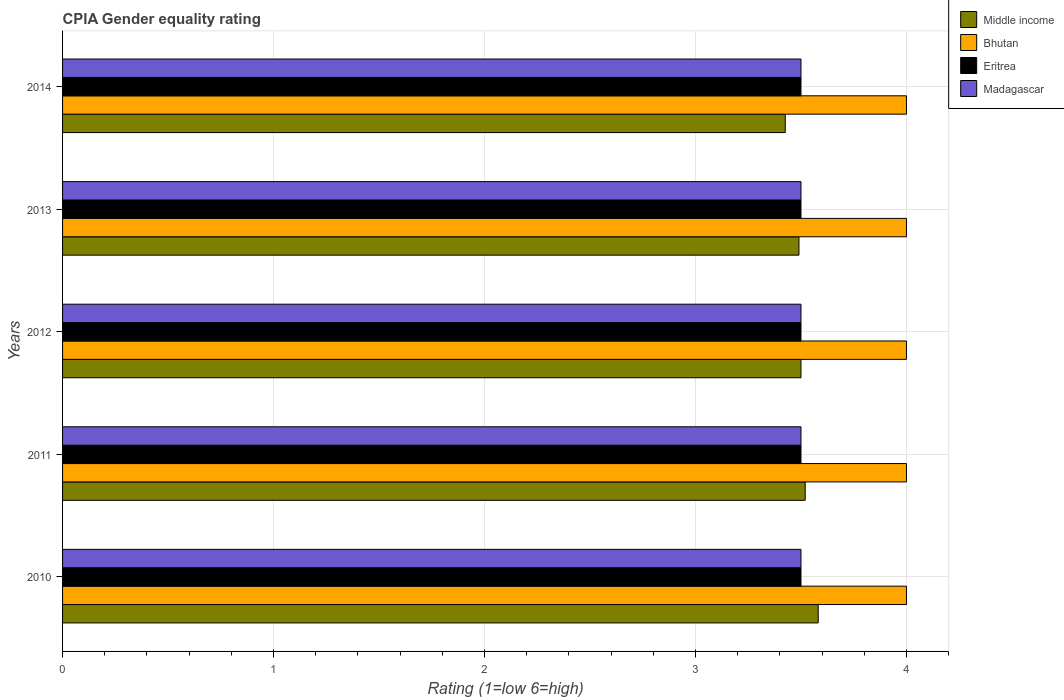How many different coloured bars are there?
Provide a short and direct response. 4. Are the number of bars per tick equal to the number of legend labels?
Your response must be concise. Yes. How many bars are there on the 5th tick from the top?
Provide a short and direct response. 4. In how many cases, is the number of bars for a given year not equal to the number of legend labels?
Your response must be concise. 0. What is the CPIA rating in Middle income in 2014?
Keep it short and to the point. 3.43. Across all years, what is the maximum CPIA rating in Bhutan?
Your answer should be very brief. 4. In which year was the CPIA rating in Bhutan minimum?
Your answer should be compact. 2010. What is the difference between the CPIA rating in Madagascar in 2010 and the CPIA rating in Eritrea in 2012?
Offer a very short reply. 0. In the year 2010, what is the difference between the CPIA rating in Bhutan and CPIA rating in Middle income?
Ensure brevity in your answer.  0.42. What is the difference between the highest and the second highest CPIA rating in Middle income?
Offer a very short reply. 0.06. What is the difference between the highest and the lowest CPIA rating in Middle income?
Provide a short and direct response. 0.16. Is it the case that in every year, the sum of the CPIA rating in Bhutan and CPIA rating in Madagascar is greater than the sum of CPIA rating in Middle income and CPIA rating in Eritrea?
Your answer should be very brief. Yes. What does the 2nd bar from the top in 2014 represents?
Your answer should be compact. Eritrea. What does the 3rd bar from the bottom in 2010 represents?
Your answer should be compact. Eritrea. Is it the case that in every year, the sum of the CPIA rating in Middle income and CPIA rating in Bhutan is greater than the CPIA rating in Eritrea?
Give a very brief answer. Yes. Are all the bars in the graph horizontal?
Your answer should be very brief. Yes. Are the values on the major ticks of X-axis written in scientific E-notation?
Your answer should be very brief. No. Does the graph contain any zero values?
Your answer should be compact. No. How many legend labels are there?
Make the answer very short. 4. What is the title of the graph?
Ensure brevity in your answer.  CPIA Gender equality rating. What is the label or title of the X-axis?
Your answer should be compact. Rating (1=low 6=high). What is the Rating (1=low 6=high) in Middle income in 2010?
Keep it short and to the point. 3.58. What is the Rating (1=low 6=high) in Middle income in 2011?
Provide a short and direct response. 3.52. What is the Rating (1=low 6=high) in Madagascar in 2011?
Your answer should be very brief. 3.5. What is the Rating (1=low 6=high) in Eritrea in 2012?
Your answer should be very brief. 3.5. What is the Rating (1=low 6=high) in Madagascar in 2012?
Make the answer very short. 3.5. What is the Rating (1=low 6=high) in Middle income in 2013?
Offer a terse response. 3.49. What is the Rating (1=low 6=high) in Bhutan in 2013?
Your response must be concise. 4. What is the Rating (1=low 6=high) of Middle income in 2014?
Provide a short and direct response. 3.43. What is the Rating (1=low 6=high) in Eritrea in 2014?
Your answer should be compact. 3.5. What is the Rating (1=low 6=high) of Madagascar in 2014?
Your response must be concise. 3.5. Across all years, what is the maximum Rating (1=low 6=high) in Middle income?
Your answer should be compact. 3.58. Across all years, what is the maximum Rating (1=low 6=high) in Madagascar?
Keep it short and to the point. 3.5. Across all years, what is the minimum Rating (1=low 6=high) in Middle income?
Offer a very short reply. 3.43. Across all years, what is the minimum Rating (1=low 6=high) in Madagascar?
Your response must be concise. 3.5. What is the total Rating (1=low 6=high) in Middle income in the graph?
Provide a short and direct response. 17.52. What is the difference between the Rating (1=low 6=high) of Middle income in 2010 and that in 2011?
Your answer should be compact. 0.06. What is the difference between the Rating (1=low 6=high) in Madagascar in 2010 and that in 2011?
Keep it short and to the point. 0. What is the difference between the Rating (1=low 6=high) of Middle income in 2010 and that in 2012?
Your answer should be compact. 0.08. What is the difference between the Rating (1=low 6=high) in Eritrea in 2010 and that in 2012?
Your response must be concise. 0. What is the difference between the Rating (1=low 6=high) in Madagascar in 2010 and that in 2012?
Ensure brevity in your answer.  0. What is the difference between the Rating (1=low 6=high) of Middle income in 2010 and that in 2013?
Your response must be concise. 0.09. What is the difference between the Rating (1=low 6=high) of Bhutan in 2010 and that in 2013?
Offer a terse response. 0. What is the difference between the Rating (1=low 6=high) in Madagascar in 2010 and that in 2013?
Provide a short and direct response. 0. What is the difference between the Rating (1=low 6=high) of Middle income in 2010 and that in 2014?
Keep it short and to the point. 0.16. What is the difference between the Rating (1=low 6=high) in Eritrea in 2010 and that in 2014?
Keep it short and to the point. 0. What is the difference between the Rating (1=low 6=high) of Bhutan in 2011 and that in 2012?
Provide a succinct answer. 0. What is the difference between the Rating (1=low 6=high) of Middle income in 2011 and that in 2013?
Offer a terse response. 0.03. What is the difference between the Rating (1=low 6=high) in Bhutan in 2011 and that in 2013?
Your answer should be compact. 0. What is the difference between the Rating (1=low 6=high) in Eritrea in 2011 and that in 2013?
Offer a very short reply. 0. What is the difference between the Rating (1=low 6=high) in Madagascar in 2011 and that in 2013?
Your answer should be compact. 0. What is the difference between the Rating (1=low 6=high) in Middle income in 2011 and that in 2014?
Your answer should be very brief. 0.09. What is the difference between the Rating (1=low 6=high) in Eritrea in 2011 and that in 2014?
Provide a short and direct response. 0. What is the difference between the Rating (1=low 6=high) in Madagascar in 2011 and that in 2014?
Give a very brief answer. 0. What is the difference between the Rating (1=low 6=high) of Middle income in 2012 and that in 2013?
Offer a very short reply. 0.01. What is the difference between the Rating (1=low 6=high) in Bhutan in 2012 and that in 2013?
Offer a very short reply. 0. What is the difference between the Rating (1=low 6=high) in Eritrea in 2012 and that in 2013?
Provide a short and direct response. 0. What is the difference between the Rating (1=low 6=high) of Madagascar in 2012 and that in 2013?
Ensure brevity in your answer.  0. What is the difference between the Rating (1=low 6=high) of Middle income in 2012 and that in 2014?
Make the answer very short. 0.07. What is the difference between the Rating (1=low 6=high) in Bhutan in 2012 and that in 2014?
Offer a very short reply. 0. What is the difference between the Rating (1=low 6=high) of Eritrea in 2012 and that in 2014?
Your answer should be very brief. 0. What is the difference between the Rating (1=low 6=high) in Madagascar in 2012 and that in 2014?
Provide a succinct answer. 0. What is the difference between the Rating (1=low 6=high) in Middle income in 2013 and that in 2014?
Ensure brevity in your answer.  0.06. What is the difference between the Rating (1=low 6=high) in Middle income in 2010 and the Rating (1=low 6=high) in Bhutan in 2011?
Make the answer very short. -0.42. What is the difference between the Rating (1=low 6=high) in Middle income in 2010 and the Rating (1=low 6=high) in Eritrea in 2011?
Offer a very short reply. 0.08. What is the difference between the Rating (1=low 6=high) of Middle income in 2010 and the Rating (1=low 6=high) of Madagascar in 2011?
Ensure brevity in your answer.  0.08. What is the difference between the Rating (1=low 6=high) of Bhutan in 2010 and the Rating (1=low 6=high) of Eritrea in 2011?
Offer a very short reply. 0.5. What is the difference between the Rating (1=low 6=high) in Eritrea in 2010 and the Rating (1=low 6=high) in Madagascar in 2011?
Your answer should be very brief. 0. What is the difference between the Rating (1=low 6=high) in Middle income in 2010 and the Rating (1=low 6=high) in Bhutan in 2012?
Give a very brief answer. -0.42. What is the difference between the Rating (1=low 6=high) in Middle income in 2010 and the Rating (1=low 6=high) in Eritrea in 2012?
Ensure brevity in your answer.  0.08. What is the difference between the Rating (1=low 6=high) of Middle income in 2010 and the Rating (1=low 6=high) of Madagascar in 2012?
Give a very brief answer. 0.08. What is the difference between the Rating (1=low 6=high) in Bhutan in 2010 and the Rating (1=low 6=high) in Eritrea in 2012?
Give a very brief answer. 0.5. What is the difference between the Rating (1=low 6=high) of Middle income in 2010 and the Rating (1=low 6=high) of Bhutan in 2013?
Offer a very short reply. -0.42. What is the difference between the Rating (1=low 6=high) in Middle income in 2010 and the Rating (1=low 6=high) in Eritrea in 2013?
Offer a very short reply. 0.08. What is the difference between the Rating (1=low 6=high) of Middle income in 2010 and the Rating (1=low 6=high) of Madagascar in 2013?
Provide a short and direct response. 0.08. What is the difference between the Rating (1=low 6=high) in Middle income in 2010 and the Rating (1=low 6=high) in Bhutan in 2014?
Your answer should be compact. -0.42. What is the difference between the Rating (1=low 6=high) in Middle income in 2010 and the Rating (1=low 6=high) in Eritrea in 2014?
Offer a very short reply. 0.08. What is the difference between the Rating (1=low 6=high) of Middle income in 2010 and the Rating (1=low 6=high) of Madagascar in 2014?
Offer a very short reply. 0.08. What is the difference between the Rating (1=low 6=high) of Eritrea in 2010 and the Rating (1=low 6=high) of Madagascar in 2014?
Offer a terse response. 0. What is the difference between the Rating (1=low 6=high) in Middle income in 2011 and the Rating (1=low 6=high) in Bhutan in 2012?
Give a very brief answer. -0.48. What is the difference between the Rating (1=low 6=high) of Eritrea in 2011 and the Rating (1=low 6=high) of Madagascar in 2012?
Ensure brevity in your answer.  0. What is the difference between the Rating (1=low 6=high) of Middle income in 2011 and the Rating (1=low 6=high) of Bhutan in 2013?
Provide a short and direct response. -0.48. What is the difference between the Rating (1=low 6=high) of Middle income in 2011 and the Rating (1=low 6=high) of Eritrea in 2013?
Your answer should be compact. 0.02. What is the difference between the Rating (1=low 6=high) of Middle income in 2011 and the Rating (1=low 6=high) of Madagascar in 2013?
Keep it short and to the point. 0.02. What is the difference between the Rating (1=low 6=high) of Bhutan in 2011 and the Rating (1=low 6=high) of Madagascar in 2013?
Your answer should be very brief. 0.5. What is the difference between the Rating (1=low 6=high) of Eritrea in 2011 and the Rating (1=low 6=high) of Madagascar in 2013?
Provide a short and direct response. 0. What is the difference between the Rating (1=low 6=high) of Middle income in 2011 and the Rating (1=low 6=high) of Bhutan in 2014?
Your response must be concise. -0.48. What is the difference between the Rating (1=low 6=high) of Middle income in 2011 and the Rating (1=low 6=high) of Eritrea in 2014?
Offer a terse response. 0.02. What is the difference between the Rating (1=low 6=high) of Middle income in 2011 and the Rating (1=low 6=high) of Madagascar in 2014?
Keep it short and to the point. 0.02. What is the difference between the Rating (1=low 6=high) in Bhutan in 2011 and the Rating (1=low 6=high) in Eritrea in 2014?
Your answer should be very brief. 0.5. What is the difference between the Rating (1=low 6=high) of Bhutan in 2012 and the Rating (1=low 6=high) of Eritrea in 2013?
Your answer should be very brief. 0.5. What is the difference between the Rating (1=low 6=high) in Bhutan in 2012 and the Rating (1=low 6=high) in Madagascar in 2013?
Ensure brevity in your answer.  0.5. What is the difference between the Rating (1=low 6=high) of Eritrea in 2012 and the Rating (1=low 6=high) of Madagascar in 2013?
Offer a very short reply. 0. What is the difference between the Rating (1=low 6=high) of Middle income in 2012 and the Rating (1=low 6=high) of Bhutan in 2014?
Keep it short and to the point. -0.5. What is the difference between the Rating (1=low 6=high) of Middle income in 2012 and the Rating (1=low 6=high) of Madagascar in 2014?
Provide a short and direct response. 0. What is the difference between the Rating (1=low 6=high) in Eritrea in 2012 and the Rating (1=low 6=high) in Madagascar in 2014?
Offer a very short reply. 0. What is the difference between the Rating (1=low 6=high) in Middle income in 2013 and the Rating (1=low 6=high) in Bhutan in 2014?
Provide a short and direct response. -0.51. What is the difference between the Rating (1=low 6=high) of Middle income in 2013 and the Rating (1=low 6=high) of Eritrea in 2014?
Your response must be concise. -0.01. What is the difference between the Rating (1=low 6=high) of Middle income in 2013 and the Rating (1=low 6=high) of Madagascar in 2014?
Provide a short and direct response. -0.01. What is the difference between the Rating (1=low 6=high) of Bhutan in 2013 and the Rating (1=low 6=high) of Madagascar in 2014?
Make the answer very short. 0.5. What is the difference between the Rating (1=low 6=high) of Eritrea in 2013 and the Rating (1=low 6=high) of Madagascar in 2014?
Offer a terse response. 0. What is the average Rating (1=low 6=high) of Middle income per year?
Provide a short and direct response. 3.5. What is the average Rating (1=low 6=high) of Bhutan per year?
Provide a succinct answer. 4. What is the average Rating (1=low 6=high) in Madagascar per year?
Ensure brevity in your answer.  3.5. In the year 2010, what is the difference between the Rating (1=low 6=high) of Middle income and Rating (1=low 6=high) of Bhutan?
Keep it short and to the point. -0.42. In the year 2010, what is the difference between the Rating (1=low 6=high) in Middle income and Rating (1=low 6=high) in Eritrea?
Ensure brevity in your answer.  0.08. In the year 2010, what is the difference between the Rating (1=low 6=high) in Middle income and Rating (1=low 6=high) in Madagascar?
Offer a very short reply. 0.08. In the year 2010, what is the difference between the Rating (1=low 6=high) of Bhutan and Rating (1=low 6=high) of Eritrea?
Give a very brief answer. 0.5. In the year 2011, what is the difference between the Rating (1=low 6=high) in Middle income and Rating (1=low 6=high) in Bhutan?
Keep it short and to the point. -0.48. In the year 2011, what is the difference between the Rating (1=low 6=high) of Middle income and Rating (1=low 6=high) of Eritrea?
Your response must be concise. 0.02. In the year 2011, what is the difference between the Rating (1=low 6=high) of Middle income and Rating (1=low 6=high) of Madagascar?
Offer a very short reply. 0.02. In the year 2011, what is the difference between the Rating (1=low 6=high) of Bhutan and Rating (1=low 6=high) of Eritrea?
Provide a short and direct response. 0.5. In the year 2011, what is the difference between the Rating (1=low 6=high) of Bhutan and Rating (1=low 6=high) of Madagascar?
Provide a short and direct response. 0.5. In the year 2011, what is the difference between the Rating (1=low 6=high) in Eritrea and Rating (1=low 6=high) in Madagascar?
Provide a succinct answer. 0. In the year 2012, what is the difference between the Rating (1=low 6=high) in Bhutan and Rating (1=low 6=high) in Madagascar?
Provide a succinct answer. 0.5. In the year 2013, what is the difference between the Rating (1=low 6=high) in Middle income and Rating (1=low 6=high) in Bhutan?
Your response must be concise. -0.51. In the year 2013, what is the difference between the Rating (1=low 6=high) of Middle income and Rating (1=low 6=high) of Eritrea?
Keep it short and to the point. -0.01. In the year 2013, what is the difference between the Rating (1=low 6=high) of Middle income and Rating (1=low 6=high) of Madagascar?
Keep it short and to the point. -0.01. In the year 2013, what is the difference between the Rating (1=low 6=high) of Bhutan and Rating (1=low 6=high) of Madagascar?
Your answer should be compact. 0.5. In the year 2013, what is the difference between the Rating (1=low 6=high) in Eritrea and Rating (1=low 6=high) in Madagascar?
Ensure brevity in your answer.  0. In the year 2014, what is the difference between the Rating (1=low 6=high) in Middle income and Rating (1=low 6=high) in Bhutan?
Provide a short and direct response. -0.57. In the year 2014, what is the difference between the Rating (1=low 6=high) in Middle income and Rating (1=low 6=high) in Eritrea?
Provide a short and direct response. -0.07. In the year 2014, what is the difference between the Rating (1=low 6=high) of Middle income and Rating (1=low 6=high) of Madagascar?
Offer a terse response. -0.07. What is the ratio of the Rating (1=low 6=high) in Middle income in 2010 to that in 2011?
Offer a terse response. 1.02. What is the ratio of the Rating (1=low 6=high) of Bhutan in 2010 to that in 2011?
Offer a terse response. 1. What is the ratio of the Rating (1=low 6=high) in Middle income in 2010 to that in 2012?
Keep it short and to the point. 1.02. What is the ratio of the Rating (1=low 6=high) of Madagascar in 2010 to that in 2012?
Offer a very short reply. 1. What is the ratio of the Rating (1=low 6=high) of Middle income in 2010 to that in 2013?
Ensure brevity in your answer.  1.03. What is the ratio of the Rating (1=low 6=high) of Eritrea in 2010 to that in 2013?
Your response must be concise. 1. What is the ratio of the Rating (1=low 6=high) in Madagascar in 2010 to that in 2013?
Your answer should be compact. 1. What is the ratio of the Rating (1=low 6=high) of Middle income in 2010 to that in 2014?
Ensure brevity in your answer.  1.05. What is the ratio of the Rating (1=low 6=high) in Madagascar in 2010 to that in 2014?
Make the answer very short. 1. What is the ratio of the Rating (1=low 6=high) in Middle income in 2011 to that in 2013?
Provide a short and direct response. 1.01. What is the ratio of the Rating (1=low 6=high) in Bhutan in 2011 to that in 2013?
Provide a succinct answer. 1. What is the ratio of the Rating (1=low 6=high) in Eritrea in 2011 to that in 2013?
Your answer should be very brief. 1. What is the ratio of the Rating (1=low 6=high) of Middle income in 2011 to that in 2014?
Your answer should be compact. 1.03. What is the ratio of the Rating (1=low 6=high) in Bhutan in 2011 to that in 2014?
Your answer should be compact. 1. What is the ratio of the Rating (1=low 6=high) of Middle income in 2012 to that in 2013?
Keep it short and to the point. 1. What is the ratio of the Rating (1=low 6=high) of Bhutan in 2012 to that in 2013?
Your answer should be compact. 1. What is the ratio of the Rating (1=low 6=high) of Eritrea in 2012 to that in 2013?
Your answer should be very brief. 1. What is the ratio of the Rating (1=low 6=high) of Middle income in 2012 to that in 2014?
Your answer should be very brief. 1.02. What is the ratio of the Rating (1=low 6=high) of Bhutan in 2012 to that in 2014?
Make the answer very short. 1. What is the ratio of the Rating (1=low 6=high) in Eritrea in 2012 to that in 2014?
Give a very brief answer. 1. What is the ratio of the Rating (1=low 6=high) of Middle income in 2013 to that in 2014?
Ensure brevity in your answer.  1.02. What is the ratio of the Rating (1=low 6=high) in Eritrea in 2013 to that in 2014?
Your answer should be very brief. 1. What is the ratio of the Rating (1=low 6=high) of Madagascar in 2013 to that in 2014?
Your answer should be very brief. 1. What is the difference between the highest and the second highest Rating (1=low 6=high) in Middle income?
Give a very brief answer. 0.06. What is the difference between the highest and the second highest Rating (1=low 6=high) of Bhutan?
Provide a short and direct response. 0. What is the difference between the highest and the second highest Rating (1=low 6=high) of Eritrea?
Ensure brevity in your answer.  0. What is the difference between the highest and the second highest Rating (1=low 6=high) in Madagascar?
Your answer should be very brief. 0. What is the difference between the highest and the lowest Rating (1=low 6=high) in Middle income?
Offer a very short reply. 0.16. What is the difference between the highest and the lowest Rating (1=low 6=high) in Bhutan?
Provide a succinct answer. 0. What is the difference between the highest and the lowest Rating (1=low 6=high) in Eritrea?
Keep it short and to the point. 0. 